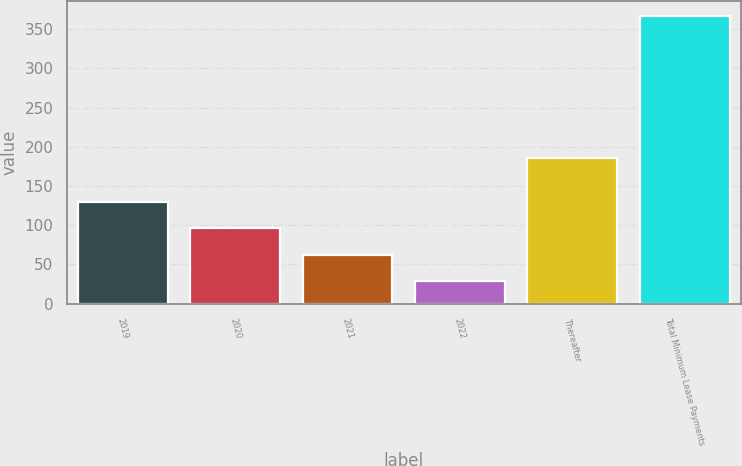Convert chart. <chart><loc_0><loc_0><loc_500><loc_500><bar_chart><fcel>2019<fcel>2020<fcel>2021<fcel>2022<fcel>Thereafter<fcel>Total Minimum Lease Payments<nl><fcel>129.98<fcel>96.12<fcel>62.26<fcel>28.4<fcel>185.8<fcel>367<nl></chart> 